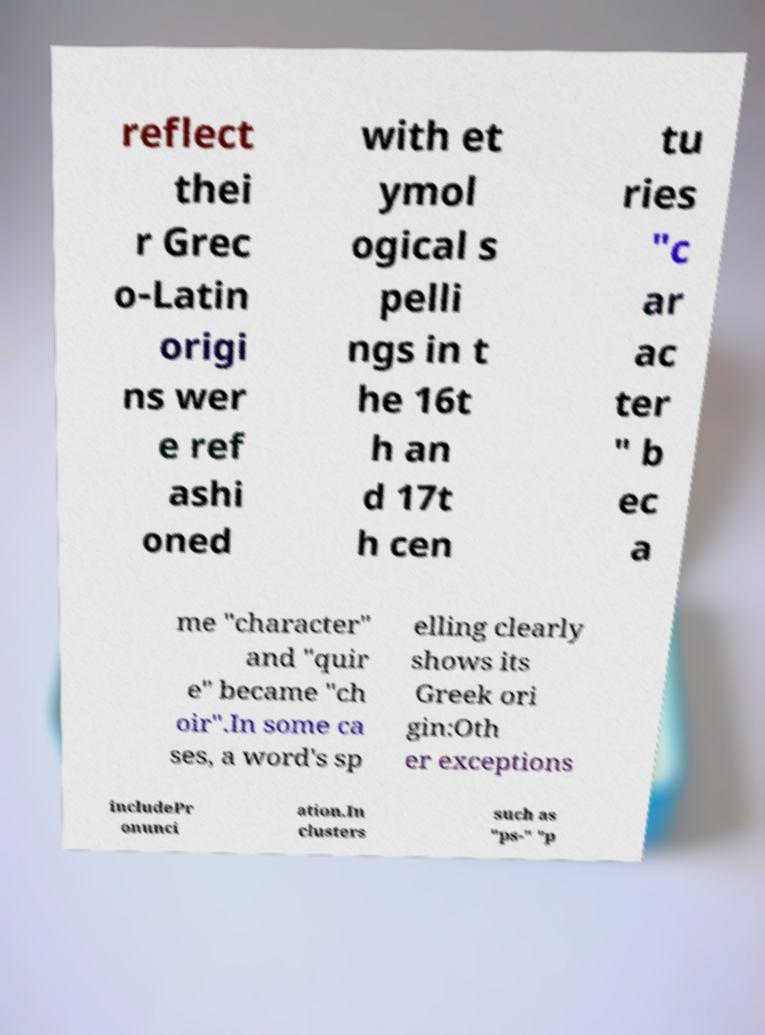Could you extract and type out the text from this image? reflect thei r Grec o-Latin origi ns wer e ref ashi oned with et ymol ogical s pelli ngs in t he 16t h an d 17t h cen tu ries "c ar ac ter " b ec a me "character" and "quir e" became "ch oir".In some ca ses, a word's sp elling clearly shows its Greek ori gin:Oth er exceptions includePr onunci ation.In clusters such as "ps-" "p 